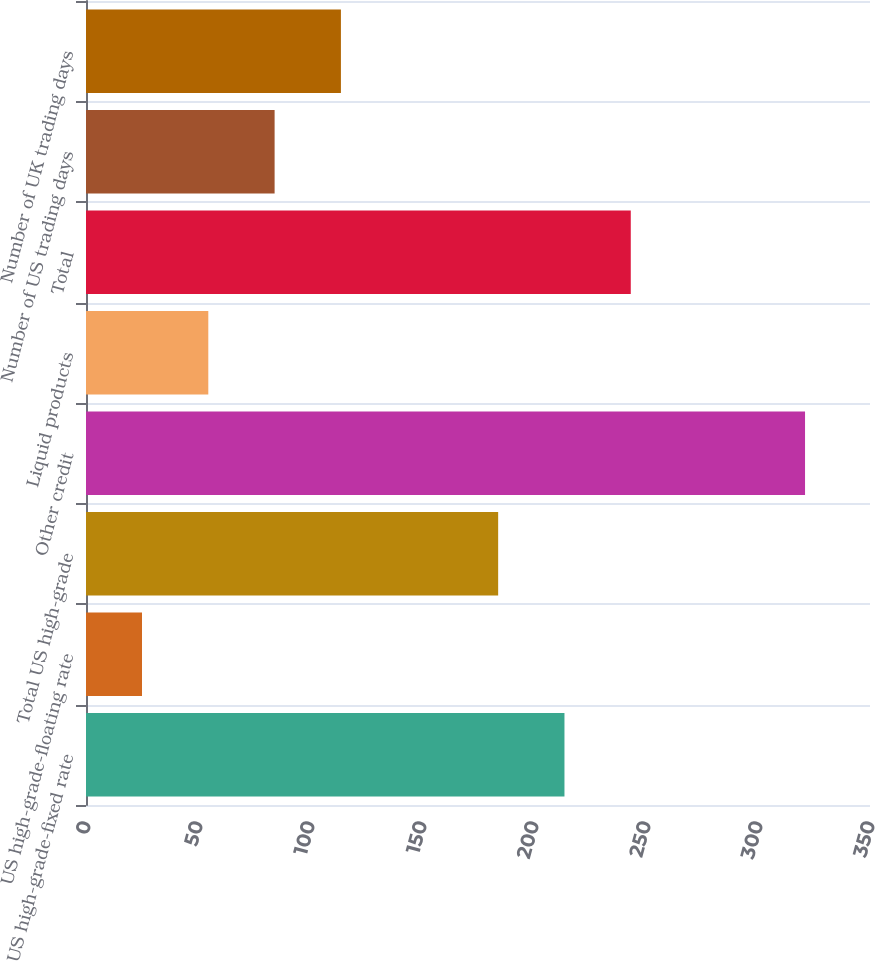<chart> <loc_0><loc_0><loc_500><loc_500><bar_chart><fcel>US high-grade-fixed rate<fcel>US high-grade-floating rate<fcel>Total US high-grade<fcel>Other credit<fcel>Liquid products<fcel>Total<fcel>Number of US trading days<fcel>Number of UK trading days<nl><fcel>213.6<fcel>25<fcel>184<fcel>321<fcel>54.6<fcel>243.2<fcel>84.2<fcel>113.8<nl></chart> 